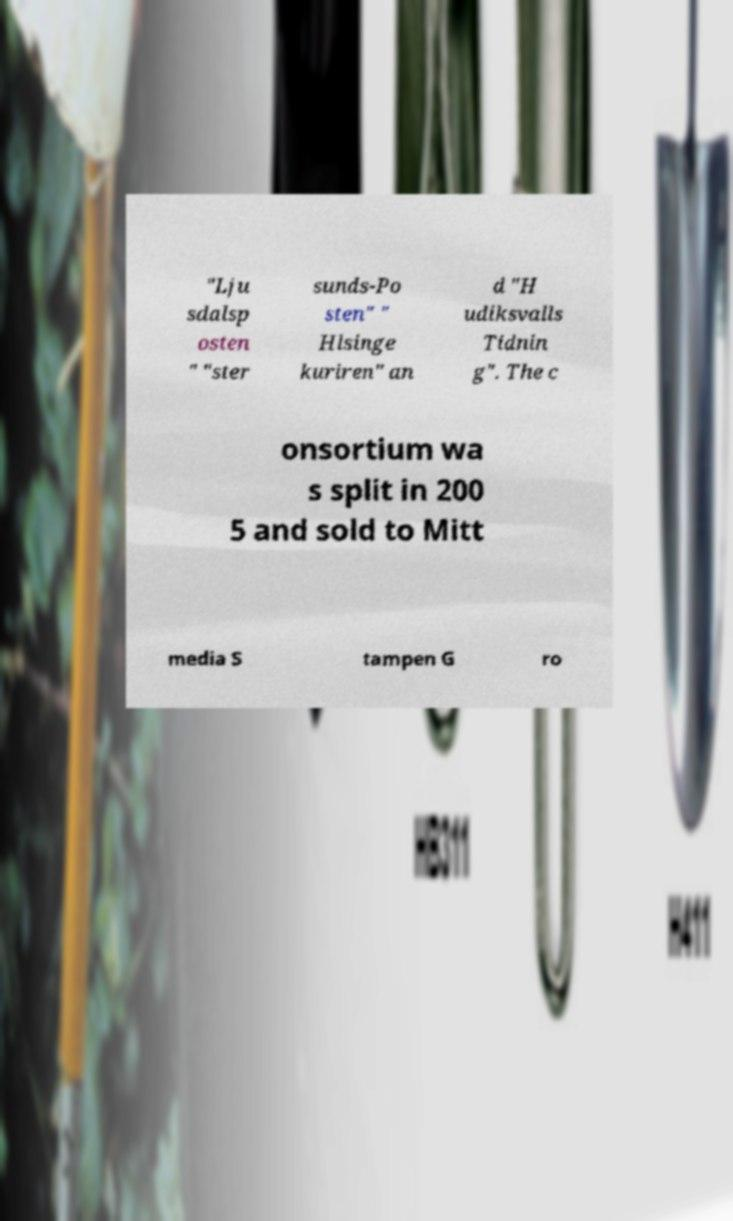For documentation purposes, I need the text within this image transcribed. Could you provide that? "Lju sdalsp osten " "ster sunds-Po sten" " Hlsinge kuriren" an d "H udiksvalls Tidnin g". The c onsortium wa s split in 200 5 and sold to Mitt media S tampen G ro 